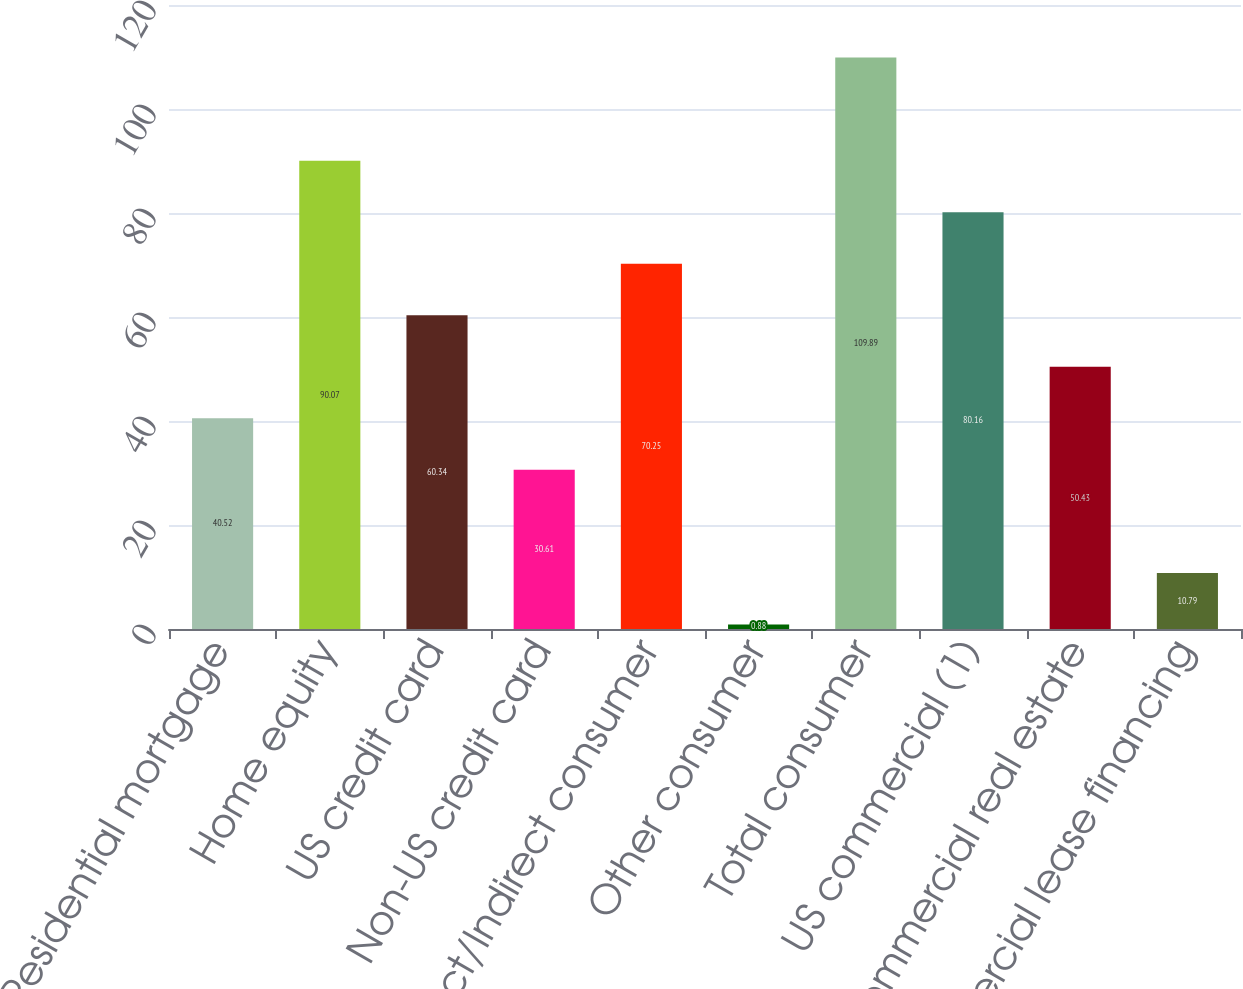<chart> <loc_0><loc_0><loc_500><loc_500><bar_chart><fcel>Residential mortgage<fcel>Home equity<fcel>US credit card<fcel>Non-US credit card<fcel>Direct/Indirect consumer<fcel>Other consumer<fcel>Total consumer<fcel>US commercial (1)<fcel>Commercial real estate<fcel>Commercial lease financing<nl><fcel>40.52<fcel>90.07<fcel>60.34<fcel>30.61<fcel>70.25<fcel>0.88<fcel>109.89<fcel>80.16<fcel>50.43<fcel>10.79<nl></chart> 